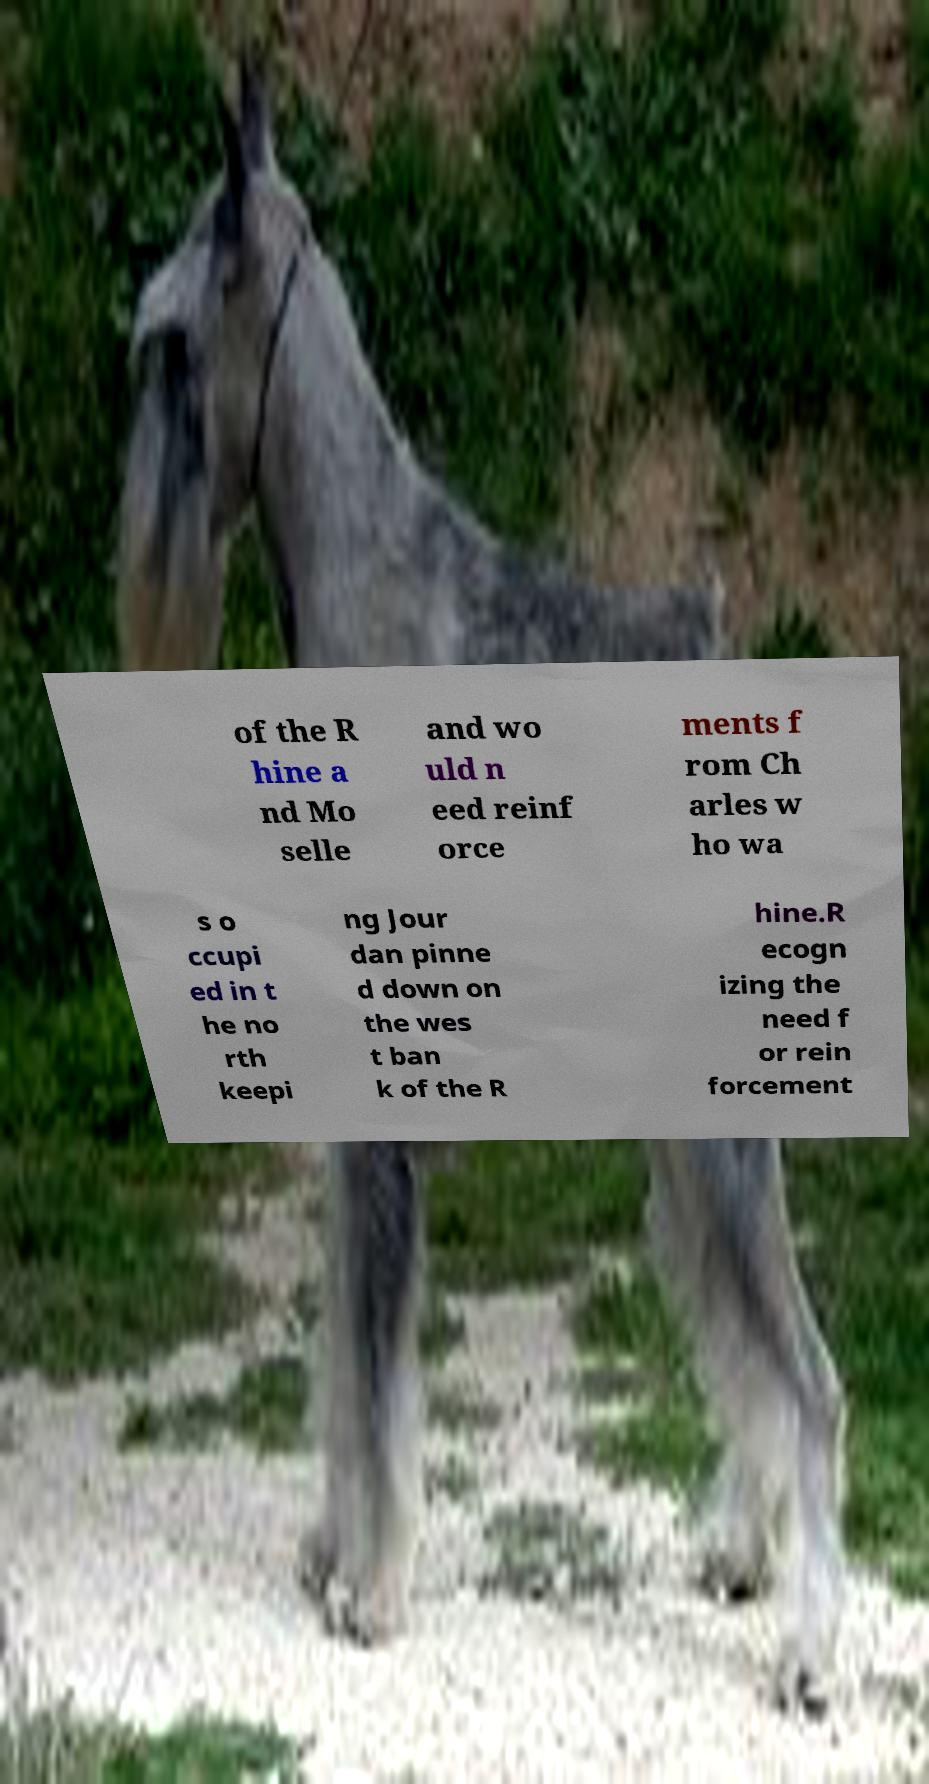For documentation purposes, I need the text within this image transcribed. Could you provide that? of the R hine a nd Mo selle and wo uld n eed reinf orce ments f rom Ch arles w ho wa s o ccupi ed in t he no rth keepi ng Jour dan pinne d down on the wes t ban k of the R hine.R ecogn izing the need f or rein forcement 